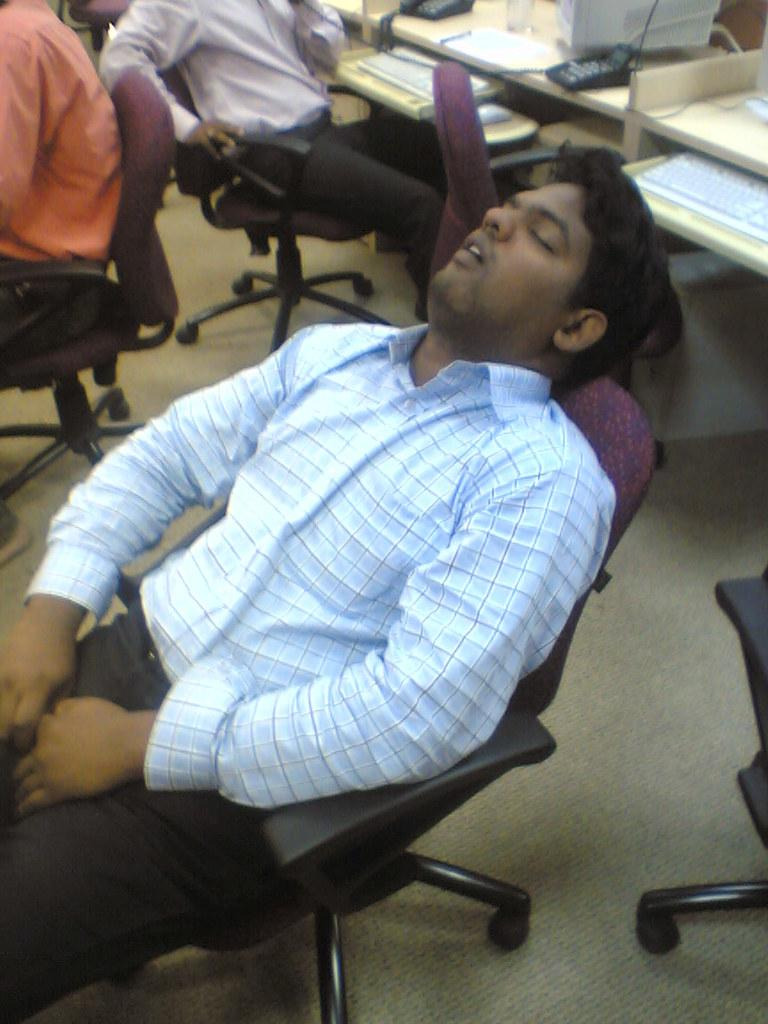How many people are sitting on chairs in the image? There are three people sitting on chairs in the image. Can you describe the gender of one of the people? One of the people is a man. What is the man doing in the image? The man is sleeping. What can be seen in the background of the image? There is a system in the background of the image. What object is present on a table in the image? There is a keyboard on a table in the image. What type of ring can be seen on the man's finger in the image? There is no ring visible on the man's finger in the image. What is the man using the hammer for in the image? There is no hammer present in the image, and the man is sleeping, not using any tools. 